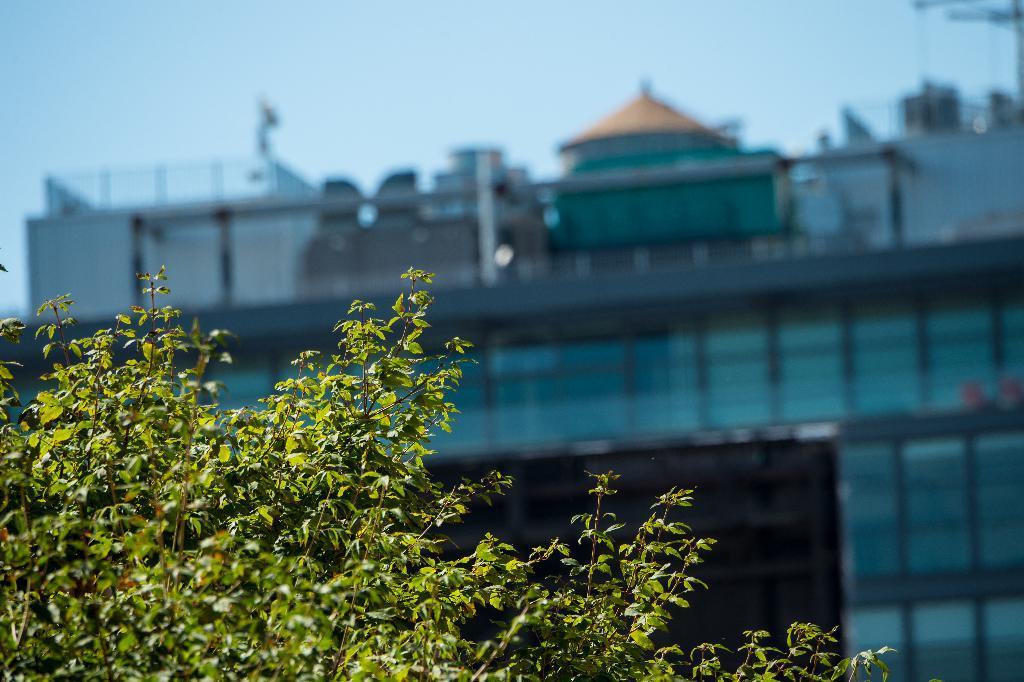Could you give a brief overview of what you see in this image? In this image in the front there are leaves. In the background there is a building and there is a tent and there is a railing. 